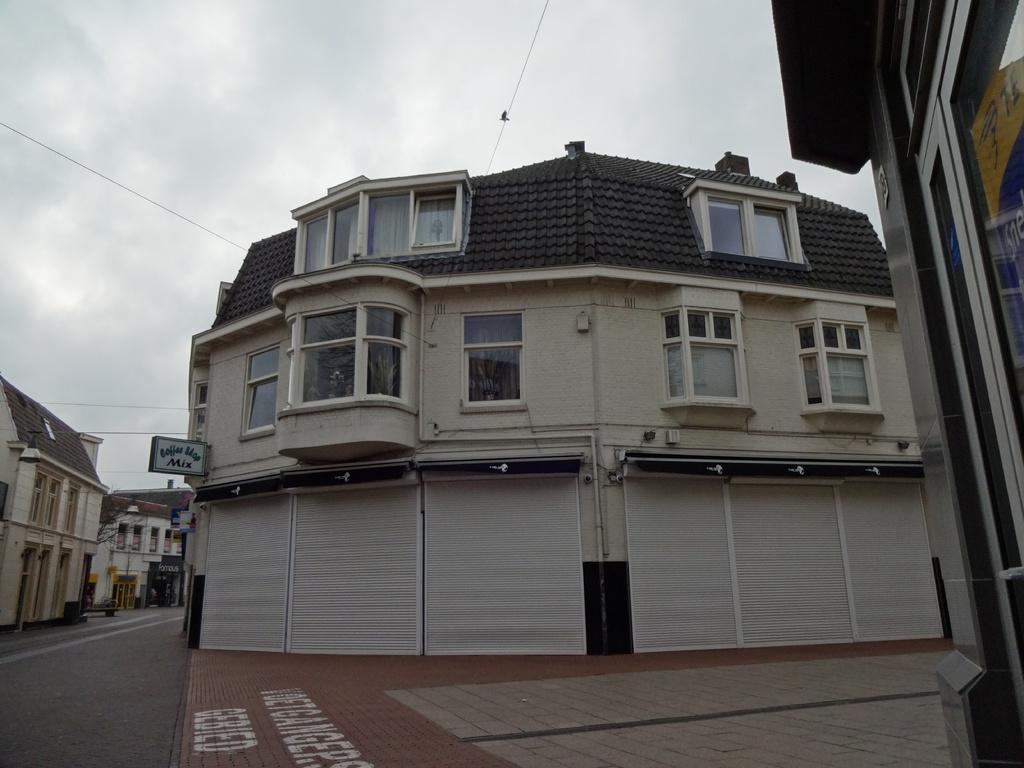Can you describe this image briefly? In this image we can see buildings, name boards, trees and sky with clouds. 